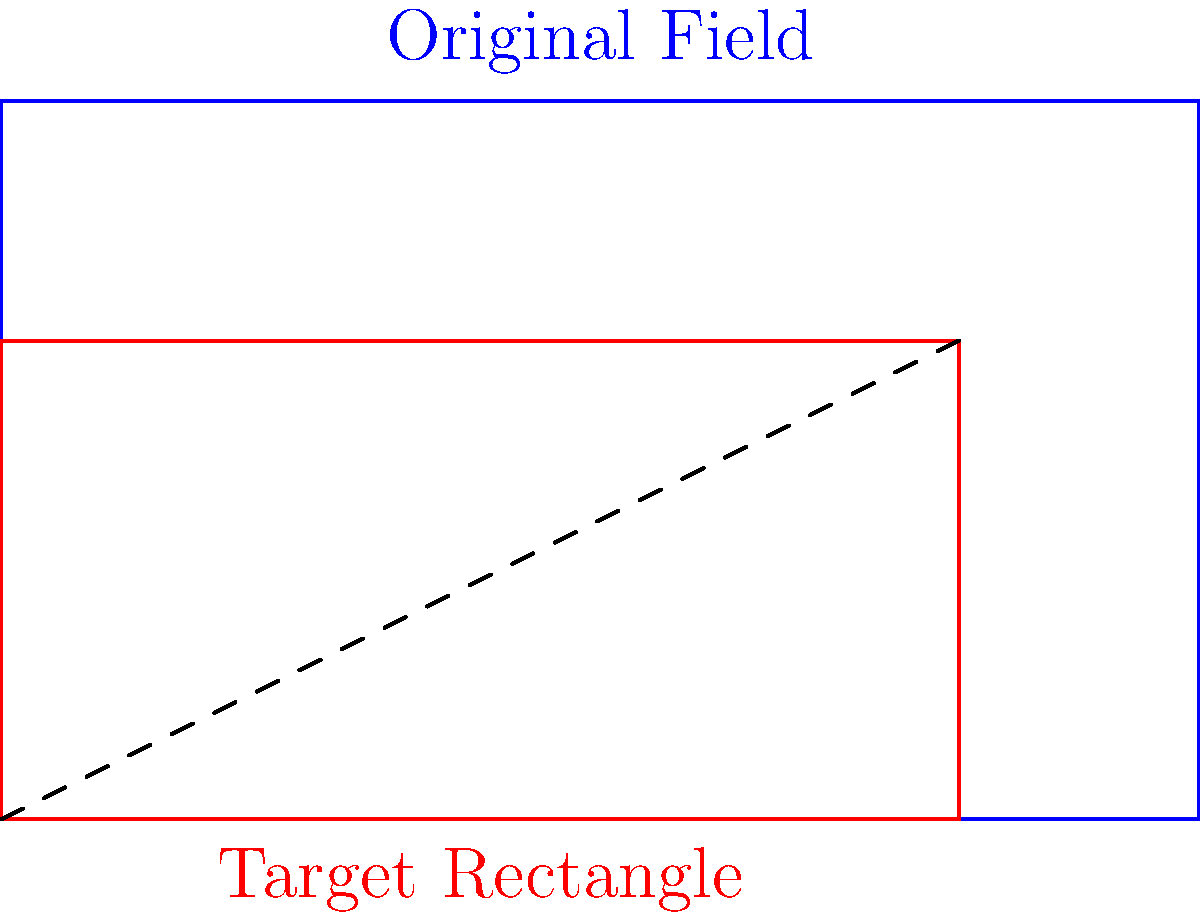The dimensions of CSM Reșița's home stadium field are 100 meters long and 60 meters wide. You want to create a scaled diagram of the field that fits exactly within a rectangle measuring 80 cm by 40 cm. What scale factor should you use to achieve this? To find the correct scale factor, we need to follow these steps:

1. Identify the original dimensions:
   Length = 100 m, Width = 60 m

2. Identify the target dimensions:
   Length = 80 cm, Width = 40 cm

3. Calculate the scale factor for length:
   $\text{Scale factor}_\text{length} = \frac{80 \text{ cm}}{100 \text{ m}} = \frac{4}{5} \text{ cm/m}$

4. Calculate the scale factor for width:
   $\text{Scale factor}_\text{width} = \frac{40 \text{ cm}}{60 \text{ m}} = \frac{2}{3} \text{ cm/m}$

5. Choose the smaller scale factor to ensure the entire field fits within the rectangle:
   $\text{Scale factor} = \min(\frac{4}{5}, \frac{2}{3}) = \frac{2}{3} \text{ cm/m}$

6. Verify the result:
   Scaled length: $100 \text{ m} \times \frac{2}{3} \text{ cm/m} = 66.67 \text{ cm}$ (fits within 80 cm)
   Scaled width: $60 \text{ m} \times \frac{2}{3} \text{ cm/m} = 40 \text{ cm}$ (exactly fits 40 cm)

Therefore, the correct scale factor is $\frac{2}{3} \text{ cm/m}$ or $0.6667 \text{ cm/m}$.
Answer: $\frac{2}{3} \text{ cm/m}$ 